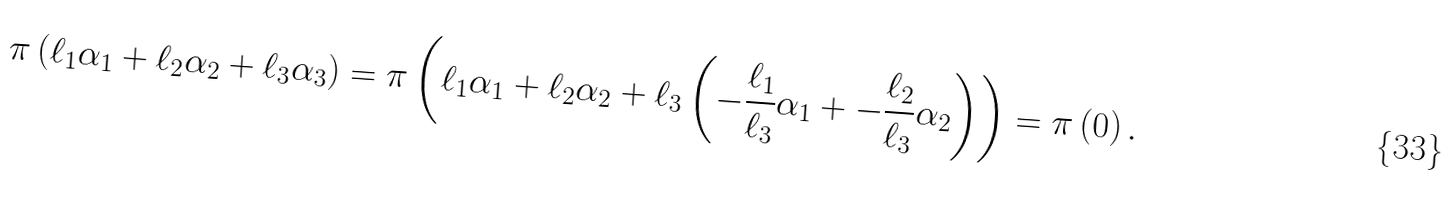<formula> <loc_0><loc_0><loc_500><loc_500>\pi \left ( \ell _ { 1 } \alpha _ { 1 } + \ell _ { 2 } \alpha _ { 2 } + \ell _ { 3 } \alpha _ { 3 } \right ) = \pi \left ( \ell _ { 1 } \alpha _ { 1 } + \ell _ { 2 } \alpha _ { 2 } + \ell _ { 3 } \left ( - \frac { \ell _ { 1 } } { \ell _ { 3 } } \alpha _ { 1 } + - \frac { \ell _ { 2 } } { \ell _ { 3 } } \alpha _ { 2 } \right ) \right ) = \pi \left ( 0 \right ) .</formula> 